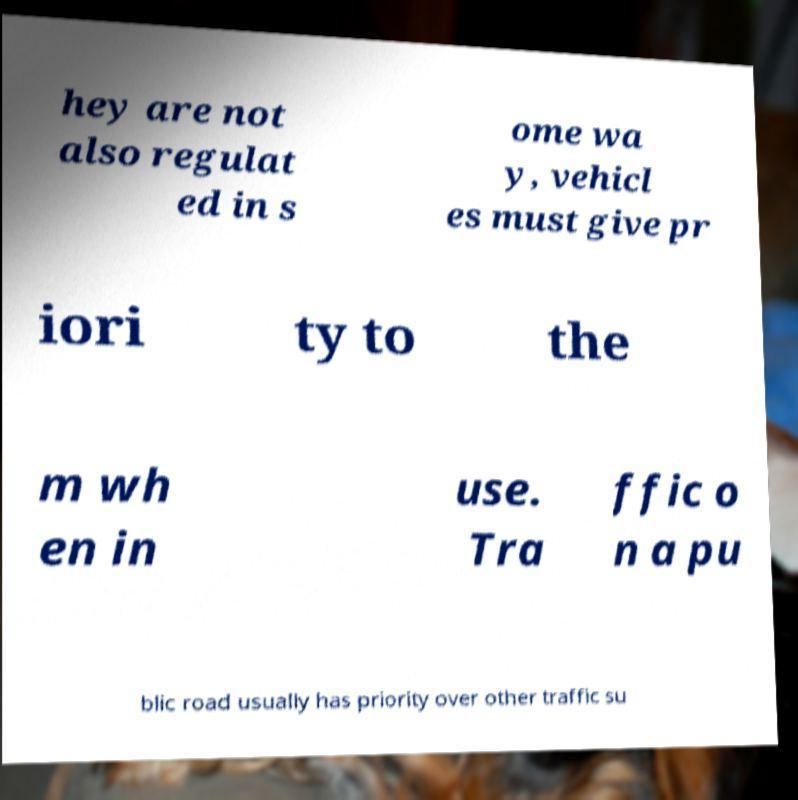Could you assist in decoding the text presented in this image and type it out clearly? hey are not also regulat ed in s ome wa y, vehicl es must give pr iori ty to the m wh en in use. Tra ffic o n a pu blic road usually has priority over other traffic su 